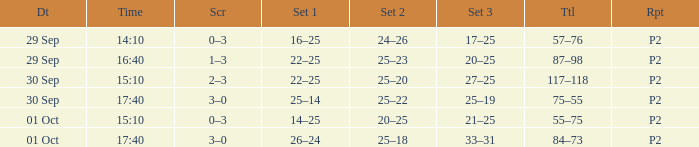What Score has a time of 14:10? 0–3. 